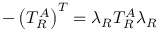<formula> <loc_0><loc_0><loc_500><loc_500>- \left ( T _ { R } ^ { A } \right ) ^ { T } = \lambda _ { R } T _ { R } ^ { A } \lambda _ { R }</formula> 